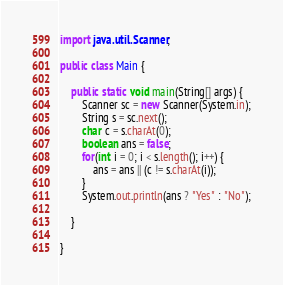Convert code to text. <code><loc_0><loc_0><loc_500><loc_500><_Java_>
import java.util.Scanner;

public class Main {

	public static void main(String[] args) {
		Scanner sc = new Scanner(System.in);
		String s = sc.next();
		char c = s.charAt(0);
		boolean ans = false;
		for(int i = 0; i < s.length(); i++) {
			ans = ans || (c != s.charAt(i));
		}
		System.out.println(ans ? "Yes" : "No");

	}

}
</code> 